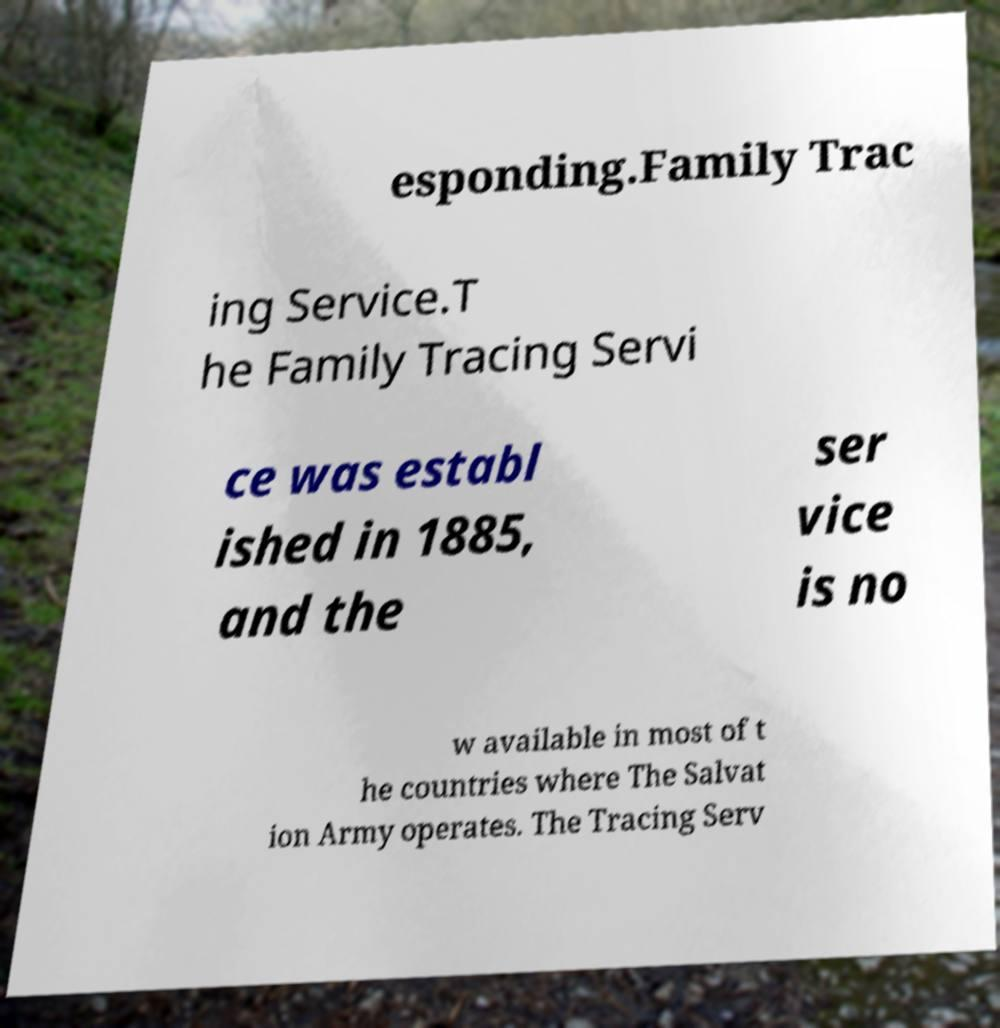Could you assist in decoding the text presented in this image and type it out clearly? esponding.Family Trac ing Service.T he Family Tracing Servi ce was establ ished in 1885, and the ser vice is no w available in most of t he countries where The Salvat ion Army operates. The Tracing Serv 